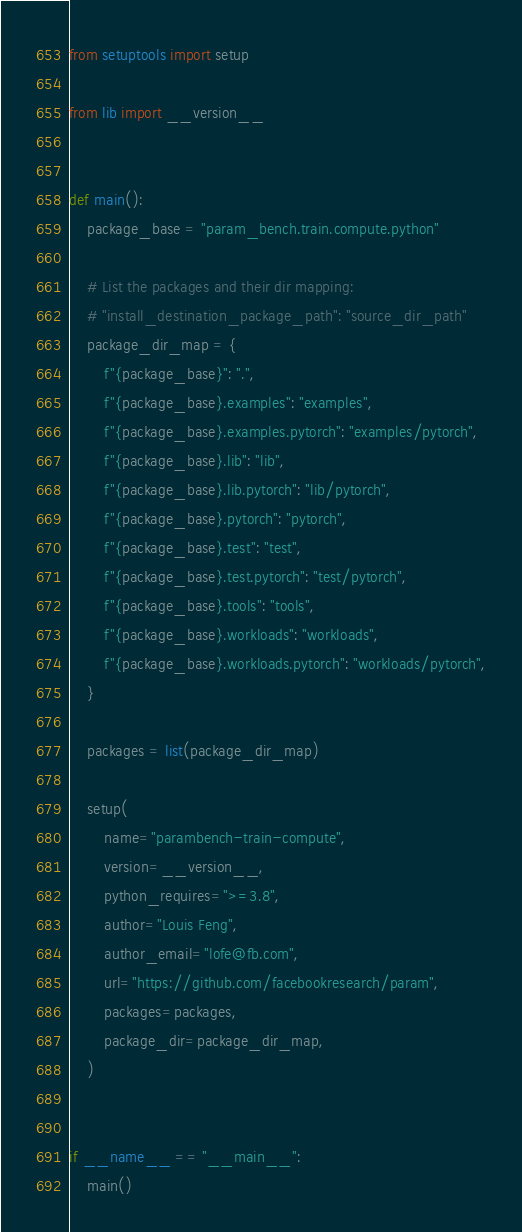Convert code to text. <code><loc_0><loc_0><loc_500><loc_500><_Python_>from setuptools import setup

from lib import __version__


def main():
    package_base = "param_bench.train.compute.python"

    # List the packages and their dir mapping:
    # "install_destination_package_path": "source_dir_path"
    package_dir_map = {
        f"{package_base}": ".",
        f"{package_base}.examples": "examples",
        f"{package_base}.examples.pytorch": "examples/pytorch",
        f"{package_base}.lib": "lib",
        f"{package_base}.lib.pytorch": "lib/pytorch",
        f"{package_base}.pytorch": "pytorch",
        f"{package_base}.test": "test",
        f"{package_base}.test.pytorch": "test/pytorch",
        f"{package_base}.tools": "tools",
        f"{package_base}.workloads": "workloads",
        f"{package_base}.workloads.pytorch": "workloads/pytorch",
    }

    packages = list(package_dir_map)

    setup(
        name="parambench-train-compute",
        version=__version__,
        python_requires=">=3.8",
        author="Louis Feng",
        author_email="lofe@fb.com",
        url="https://github.com/facebookresearch/param",
        packages=packages,
        package_dir=package_dir_map,
    )


if __name__ == "__main__":
    main()
</code> 